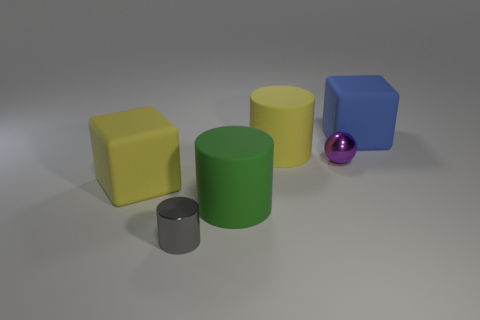Subtract all brown cylinders. Subtract all green balls. How many cylinders are left? 3 Add 3 big green matte things. How many objects exist? 9 Subtract all blocks. How many objects are left? 4 Subtract 0 cyan blocks. How many objects are left? 6 Subtract all large things. Subtract all blue rubber things. How many objects are left? 1 Add 6 big blue matte objects. How many big blue matte objects are left? 7 Add 4 tiny metallic objects. How many tiny metallic objects exist? 6 